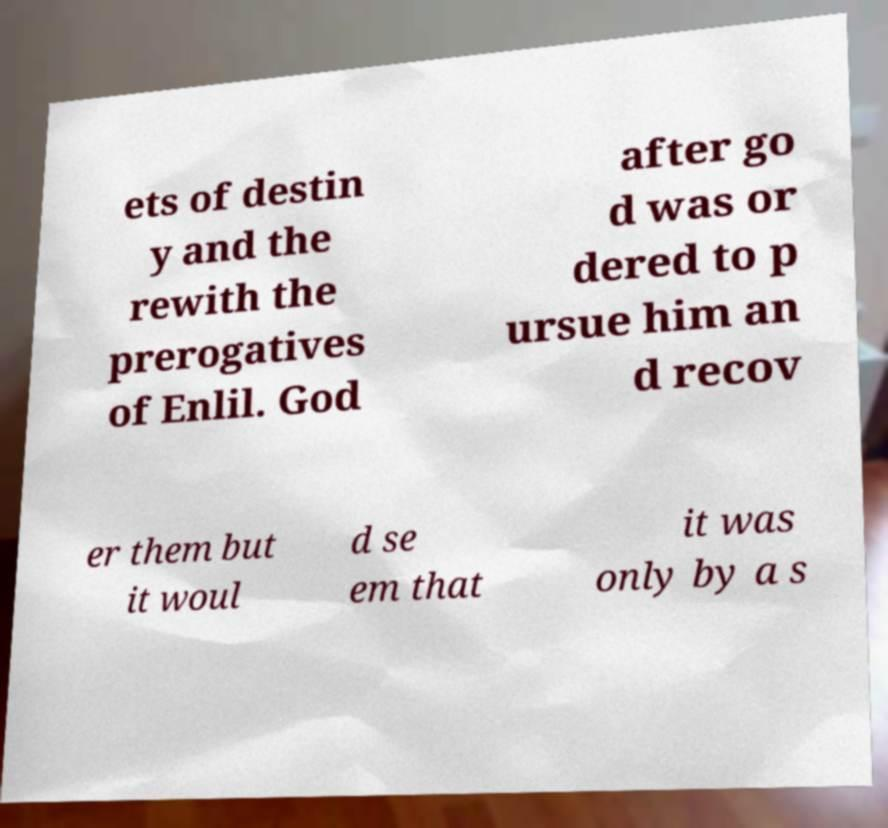For documentation purposes, I need the text within this image transcribed. Could you provide that? ets of destin y and the rewith the prerogatives of Enlil. God after go d was or dered to p ursue him an d recov er them but it woul d se em that it was only by a s 